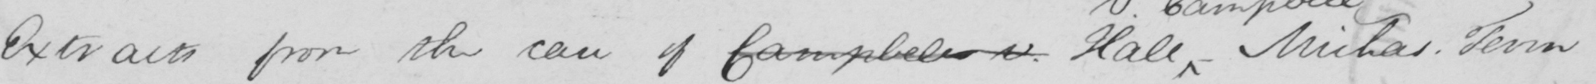What does this handwritten line say? Extracts from the case of Campbell v . Hall  _  Michas . Term 